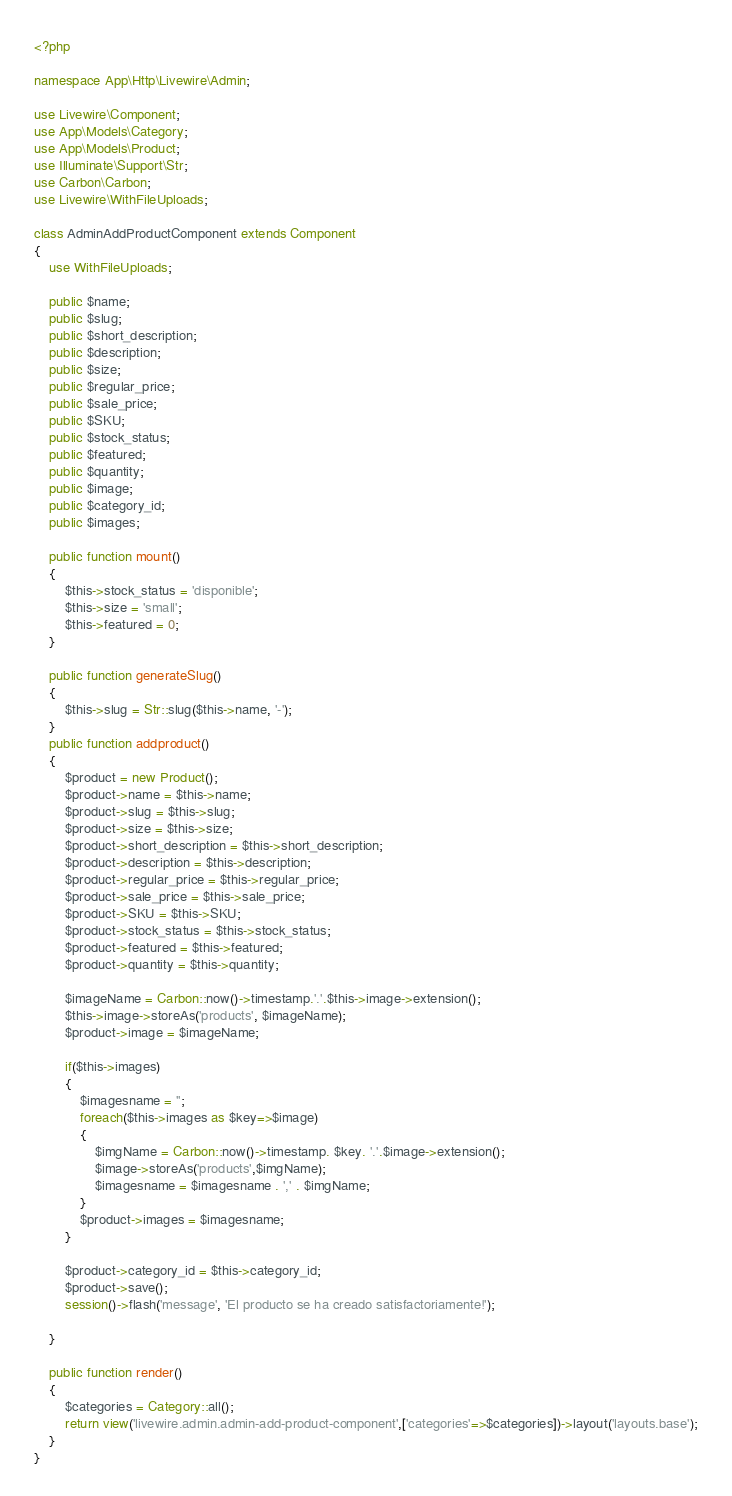Convert code to text. <code><loc_0><loc_0><loc_500><loc_500><_PHP_><?php

namespace App\Http\Livewire\Admin;

use Livewire\Component;
use App\Models\Category;
use App\Models\Product;
use Illuminate\Support\Str;
use Carbon\Carbon;
use Livewire\WithFileUploads;

class AdminAddProductComponent extends Component
{
    use WithFileUploads;

    public $name;
    public $slug;
    public $short_description;
    public $description;
    public $size;
    public $regular_price;
    public $sale_price;
    public $SKU;
    public $stock_status;
    public $featured;
    public $quantity;
    public $image;
    public $category_id;
    public $images;

    public function mount()
    {
        $this->stock_status = 'disponible';
        $this->size = 'small';
        $this->featured = 0;
    }

    public function generateSlug()
    {
        $this->slug = Str::slug($this->name, '-');
    }
    public function addproduct()
    {
        $product = new Product();
        $product->name = $this->name;
        $product->slug = $this->slug;
        $product->size = $this->size;
        $product->short_description = $this->short_description;
        $product->description = $this->description;
        $product->regular_price = $this->regular_price;
        $product->sale_price = $this->sale_price;
        $product->SKU = $this->SKU;
        $product->stock_status = $this->stock_status;
        $product->featured = $this->featured;
        $product->quantity = $this->quantity;

        $imageName = Carbon::now()->timestamp.'.'.$this->image->extension();
        $this->image->storeAs('products', $imageName);
        $product->image = $imageName;

        if($this->images)
        {
            $imagesname = '';
            foreach($this->images as $key=>$image)
            {
                $imgName = Carbon::now()->timestamp. $key. '.'.$image->extension();
                $image->storeAs('products',$imgName);
                $imagesname = $imagesname . ',' . $imgName;
            }
            $product->images = $imagesname;
        }

        $product->category_id = $this->category_id;
        $product->save();
        session()->flash('message', 'El producto se ha creado satisfactoriamente!');

    }

    public function render()
    {
        $categories = Category::all();
        return view('livewire.admin.admin-add-product-component',['categories'=>$categories])->layout('layouts.base');
    }
}
</code> 